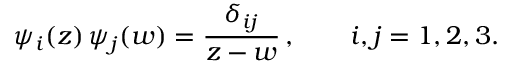Convert formula to latex. <formula><loc_0><loc_0><loc_500><loc_500>\psi _ { i } ( z ) \, \psi _ { j } ( w ) = \frac { \delta _ { i j } } { z - w } \, , \quad i , j = 1 , 2 , 3 .</formula> 